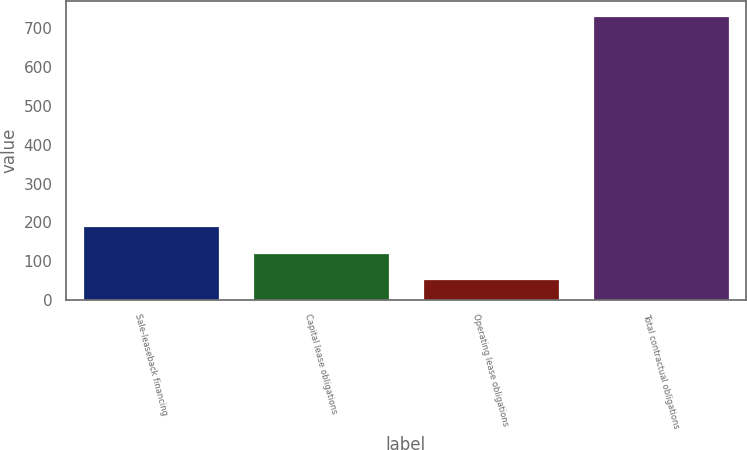Convert chart to OTSL. <chart><loc_0><loc_0><loc_500><loc_500><bar_chart><fcel>Sale-leaseback financing<fcel>Capital lease obligations<fcel>Operating lease obligations<fcel>Total contractual obligations<nl><fcel>189.8<fcel>121.9<fcel>54<fcel>733<nl></chart> 